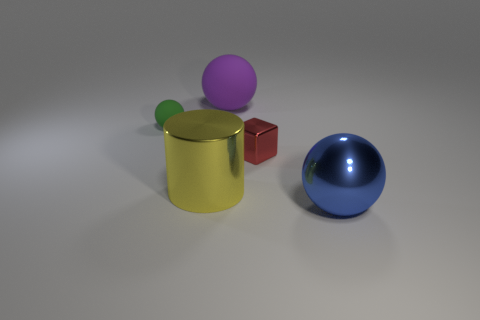Add 2 tiny rubber things. How many objects exist? 7 Subtract all big yellow shiny cylinders. Subtract all tiny green balls. How many objects are left? 3 Add 3 large balls. How many large balls are left? 5 Add 3 small green cubes. How many small green cubes exist? 3 Subtract 1 green spheres. How many objects are left? 4 Subtract all balls. How many objects are left? 2 